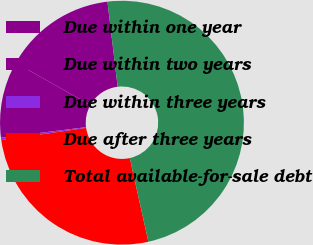Convert chart. <chart><loc_0><loc_0><loc_500><loc_500><pie_chart><fcel>Due within one year<fcel>Due within two years<fcel>Due within three years<fcel>Due after three years<fcel>Total available-for-sale debt<nl><fcel>14.94%<fcel>10.13%<fcel>0.32%<fcel>26.19%<fcel>48.42%<nl></chart> 